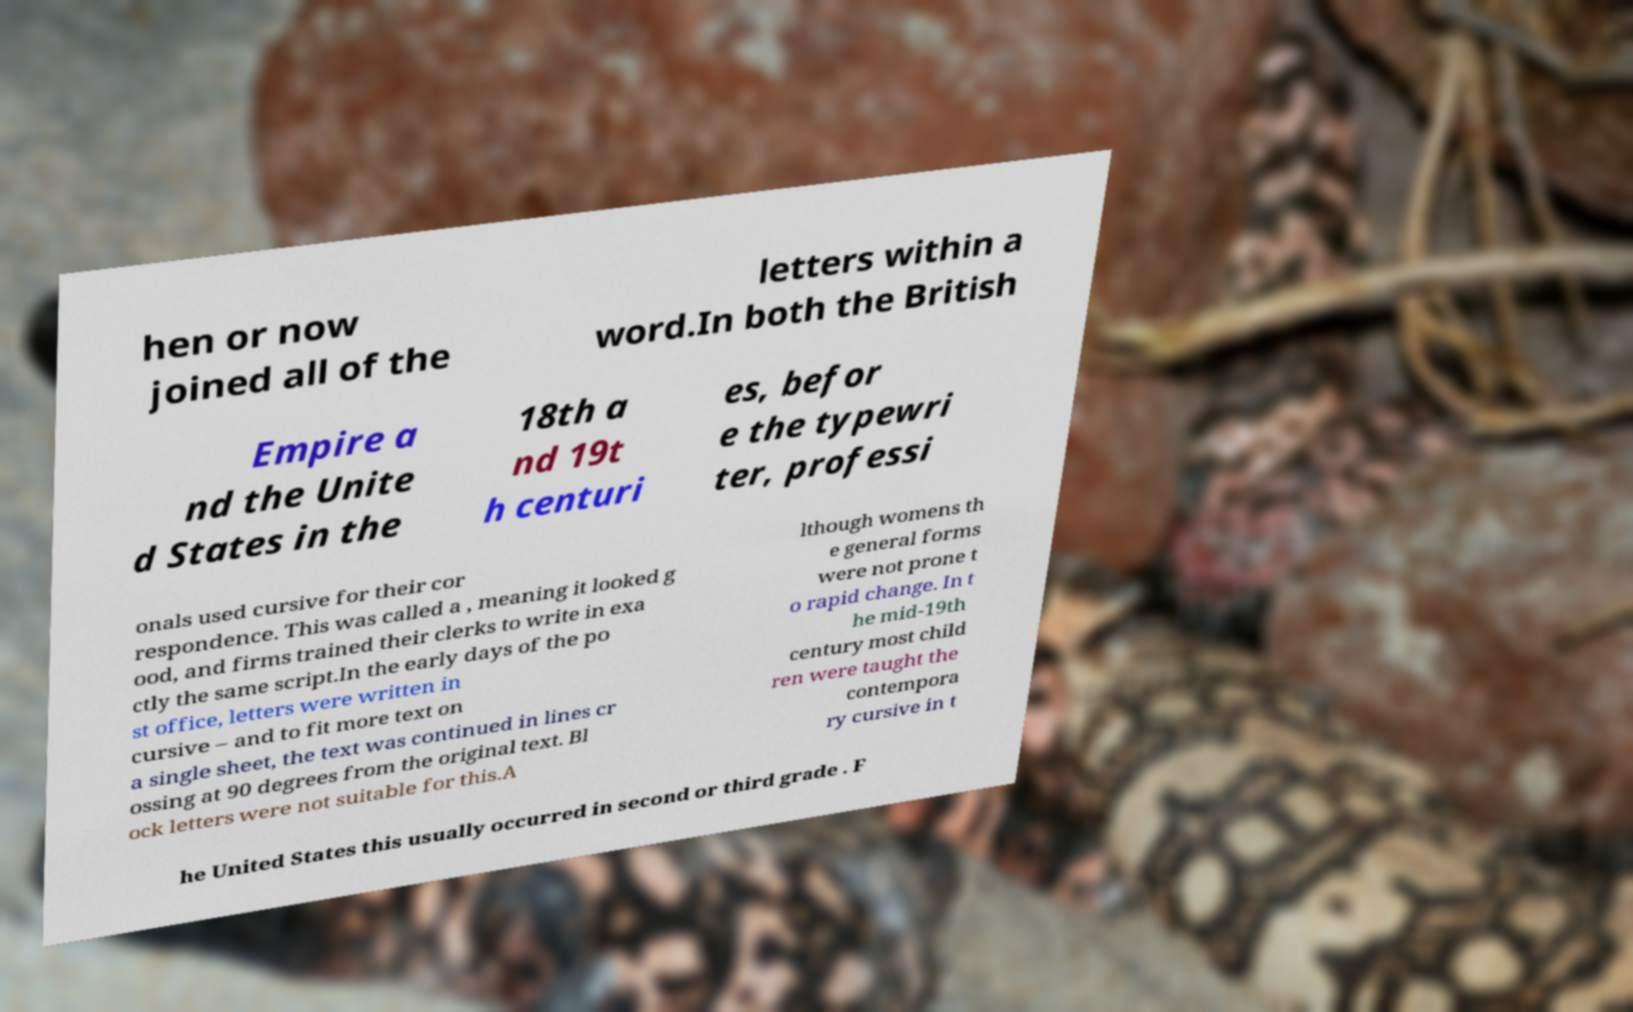What messages or text are displayed in this image? I need them in a readable, typed format. hen or now joined all of the letters within a word.In both the British Empire a nd the Unite d States in the 18th a nd 19t h centuri es, befor e the typewri ter, professi onals used cursive for their cor respondence. This was called a , meaning it looked g ood, and firms trained their clerks to write in exa ctly the same script.In the early days of the po st office, letters were written in cursive – and to fit more text on a single sheet, the text was continued in lines cr ossing at 90 degrees from the original text. Bl ock letters were not suitable for this.A lthough womens th e general forms were not prone t o rapid change. In t he mid-19th century most child ren were taught the contempora ry cursive in t he United States this usually occurred in second or third grade . F 